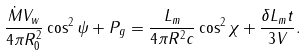Convert formula to latex. <formula><loc_0><loc_0><loc_500><loc_500>\frac { \dot { M } V _ { w } } { 4 \pi R _ { 0 } ^ { 2 } } \cos ^ { 2 } \psi + P _ { g } = \frac { L _ { m } } { 4 \pi R ^ { 2 } c } \cos ^ { 2 } \chi + \frac { \delta L _ { m } t } { 3 V } .</formula> 